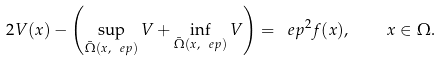Convert formula to latex. <formula><loc_0><loc_0><loc_500><loc_500>2 V ( x ) - \left ( \sup _ { \bar { \Omega } ( x , \ e p ) } V + \inf _ { \bar { \Omega } ( x , \ e p ) } V \right ) = \ e p ^ { 2 } f ( x ) , \quad x \in \Omega .</formula> 